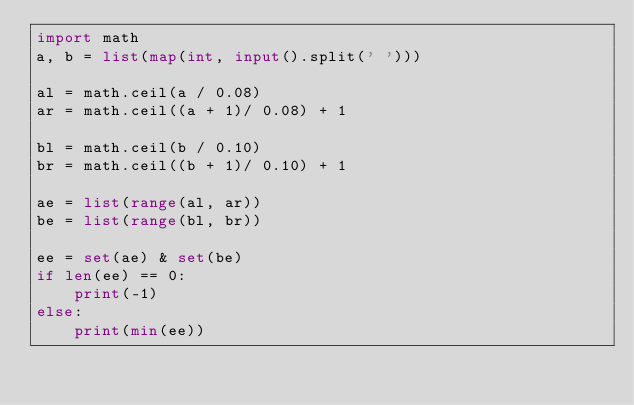<code> <loc_0><loc_0><loc_500><loc_500><_Python_>import math
a, b = list(map(int, input().split(' ')))

al = math.ceil(a / 0.08)
ar = math.ceil((a + 1)/ 0.08) + 1

bl = math.ceil(b / 0.10)
br = math.ceil((b + 1)/ 0.10) + 1

ae = list(range(al, ar))
be = list(range(bl, br))

ee = set(ae) & set(be)
if len(ee) == 0:
    print(-1)
else:
    print(min(ee))
</code> 